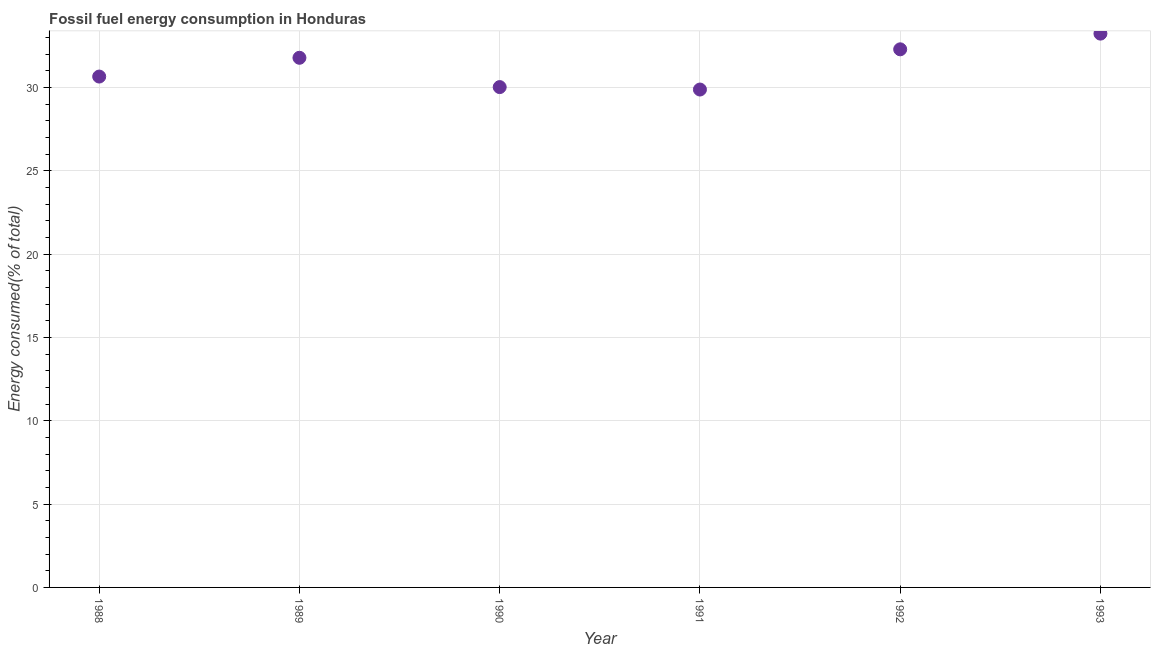What is the fossil fuel energy consumption in 1989?
Keep it short and to the point. 31.77. Across all years, what is the maximum fossil fuel energy consumption?
Your response must be concise. 33.22. Across all years, what is the minimum fossil fuel energy consumption?
Make the answer very short. 29.87. In which year was the fossil fuel energy consumption minimum?
Provide a succinct answer. 1991. What is the sum of the fossil fuel energy consumption?
Your response must be concise. 187.82. What is the difference between the fossil fuel energy consumption in 1989 and 1990?
Your answer should be very brief. 1.76. What is the average fossil fuel energy consumption per year?
Your response must be concise. 31.3. What is the median fossil fuel energy consumption?
Provide a succinct answer. 31.21. Do a majority of the years between 1993 and 1988 (inclusive) have fossil fuel energy consumption greater than 18 %?
Ensure brevity in your answer.  Yes. What is the ratio of the fossil fuel energy consumption in 1988 to that in 1993?
Keep it short and to the point. 0.92. Is the difference between the fossil fuel energy consumption in 1990 and 1992 greater than the difference between any two years?
Make the answer very short. No. What is the difference between the highest and the second highest fossil fuel energy consumption?
Offer a very short reply. 0.94. What is the difference between the highest and the lowest fossil fuel energy consumption?
Give a very brief answer. 3.35. In how many years, is the fossil fuel energy consumption greater than the average fossil fuel energy consumption taken over all years?
Provide a short and direct response. 3. Does the fossil fuel energy consumption monotonically increase over the years?
Keep it short and to the point. No. How many dotlines are there?
Your answer should be compact. 1. How many years are there in the graph?
Your answer should be compact. 6. What is the difference between two consecutive major ticks on the Y-axis?
Offer a very short reply. 5. Does the graph contain grids?
Keep it short and to the point. Yes. What is the title of the graph?
Give a very brief answer. Fossil fuel energy consumption in Honduras. What is the label or title of the X-axis?
Offer a terse response. Year. What is the label or title of the Y-axis?
Offer a very short reply. Energy consumed(% of total). What is the Energy consumed(% of total) in 1988?
Offer a terse response. 30.65. What is the Energy consumed(% of total) in 1989?
Your answer should be very brief. 31.77. What is the Energy consumed(% of total) in 1990?
Keep it short and to the point. 30.02. What is the Energy consumed(% of total) in 1991?
Keep it short and to the point. 29.87. What is the Energy consumed(% of total) in 1992?
Keep it short and to the point. 32.28. What is the Energy consumed(% of total) in 1993?
Provide a succinct answer. 33.22. What is the difference between the Energy consumed(% of total) in 1988 and 1989?
Your answer should be compact. -1.13. What is the difference between the Energy consumed(% of total) in 1988 and 1990?
Offer a terse response. 0.63. What is the difference between the Energy consumed(% of total) in 1988 and 1991?
Keep it short and to the point. 0.78. What is the difference between the Energy consumed(% of total) in 1988 and 1992?
Your answer should be very brief. -1.63. What is the difference between the Energy consumed(% of total) in 1988 and 1993?
Provide a succinct answer. -2.58. What is the difference between the Energy consumed(% of total) in 1989 and 1990?
Ensure brevity in your answer.  1.76. What is the difference between the Energy consumed(% of total) in 1989 and 1991?
Offer a terse response. 1.9. What is the difference between the Energy consumed(% of total) in 1989 and 1992?
Ensure brevity in your answer.  -0.51. What is the difference between the Energy consumed(% of total) in 1989 and 1993?
Offer a very short reply. -1.45. What is the difference between the Energy consumed(% of total) in 1990 and 1991?
Make the answer very short. 0.15. What is the difference between the Energy consumed(% of total) in 1990 and 1992?
Provide a short and direct response. -2.27. What is the difference between the Energy consumed(% of total) in 1990 and 1993?
Provide a short and direct response. -3.21. What is the difference between the Energy consumed(% of total) in 1991 and 1992?
Offer a very short reply. -2.41. What is the difference between the Energy consumed(% of total) in 1991 and 1993?
Your answer should be compact. -3.35. What is the difference between the Energy consumed(% of total) in 1992 and 1993?
Offer a terse response. -0.94. What is the ratio of the Energy consumed(% of total) in 1988 to that in 1989?
Make the answer very short. 0.96. What is the ratio of the Energy consumed(% of total) in 1988 to that in 1992?
Keep it short and to the point. 0.95. What is the ratio of the Energy consumed(% of total) in 1988 to that in 1993?
Your answer should be very brief. 0.92. What is the ratio of the Energy consumed(% of total) in 1989 to that in 1990?
Provide a succinct answer. 1.06. What is the ratio of the Energy consumed(% of total) in 1989 to that in 1991?
Make the answer very short. 1.06. What is the ratio of the Energy consumed(% of total) in 1989 to that in 1992?
Ensure brevity in your answer.  0.98. What is the ratio of the Energy consumed(% of total) in 1989 to that in 1993?
Your response must be concise. 0.96. What is the ratio of the Energy consumed(% of total) in 1990 to that in 1993?
Make the answer very short. 0.9. What is the ratio of the Energy consumed(% of total) in 1991 to that in 1992?
Offer a very short reply. 0.93. What is the ratio of the Energy consumed(% of total) in 1991 to that in 1993?
Give a very brief answer. 0.9. 